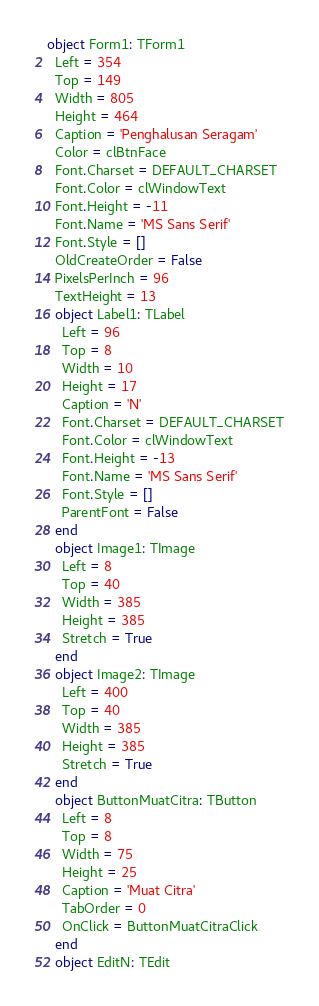<code> <loc_0><loc_0><loc_500><loc_500><_Pascal_>object Form1: TForm1
  Left = 354
  Top = 149
  Width = 805
  Height = 464
  Caption = 'Penghalusan Seragam'
  Color = clBtnFace
  Font.Charset = DEFAULT_CHARSET
  Font.Color = clWindowText
  Font.Height = -11
  Font.Name = 'MS Sans Serif'
  Font.Style = []
  OldCreateOrder = False
  PixelsPerInch = 96
  TextHeight = 13
  object Label1: TLabel
    Left = 96
    Top = 8
    Width = 10
    Height = 17
    Caption = 'N'
    Font.Charset = DEFAULT_CHARSET
    Font.Color = clWindowText
    Font.Height = -13
    Font.Name = 'MS Sans Serif'
    Font.Style = []
    ParentFont = False
  end
  object Image1: TImage
    Left = 8
    Top = 40
    Width = 385
    Height = 385
    Stretch = True
  end
  object Image2: TImage
    Left = 400
    Top = 40
    Width = 385
    Height = 385
    Stretch = True
  end
  object ButtonMuatCitra: TButton
    Left = 8
    Top = 8
    Width = 75
    Height = 25
    Caption = 'Muat Citra'
    TabOrder = 0
    OnClick = ButtonMuatCitraClick
  end
  object EditN: TEdit</code> 